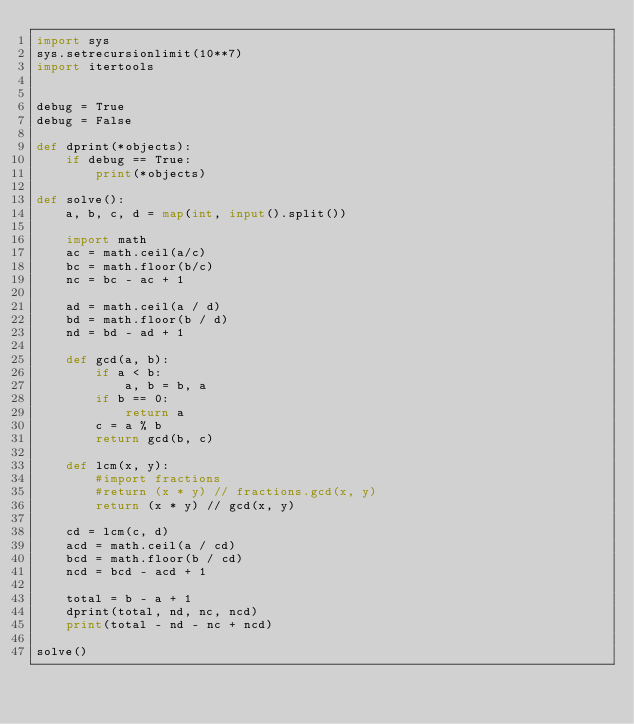Convert code to text. <code><loc_0><loc_0><loc_500><loc_500><_Python_>import sys
sys.setrecursionlimit(10**7)
import itertools


debug = True
debug = False

def dprint(*objects):
    if debug == True:
        print(*objects)

def solve():
    a, b, c, d = map(int, input().split())

    import math
    ac = math.ceil(a/c)
    bc = math.floor(b/c)
    nc = bc - ac + 1

    ad = math.ceil(a / d)
    bd = math.floor(b / d)
    nd = bd - ad + 1

    def gcd(a, b):
        if a < b:
            a, b = b, a
        if b == 0:
            return a
        c = a % b
        return gcd(b, c)

    def lcm(x, y):
        #import fractions
        #return (x * y) // fractions.gcd(x, y)
        return (x * y) // gcd(x, y)

    cd = lcm(c, d)
    acd = math.ceil(a / cd)
    bcd = math.floor(b / cd)
    ncd = bcd - acd + 1

    total = b - a + 1
    dprint(total, nd, nc, ncd)
    print(total - nd - nc + ncd)

solve()</code> 